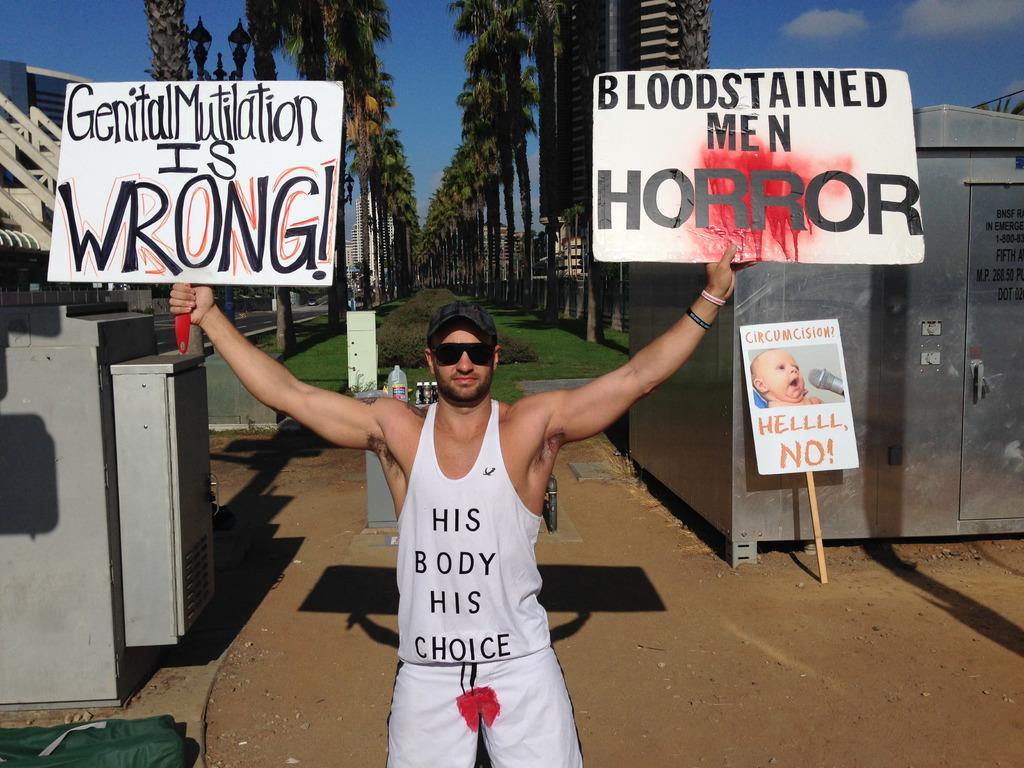Could you give a brief overview of what you see in this image? In the picture we can see a man standing and holding a two boards on one board it is written as genital mutilation is wrong and on another board it is written as a blood stained men and in the background we can see some grass, trees and sky. 